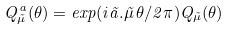<formula> <loc_0><loc_0><loc_500><loc_500>Q ^ { a } _ { \vec { \mu } } ( \theta ) = e x p ( i \vec { a } . \vec { \mu } \, \theta / 2 \pi ) Q _ { \vec { \mu } } ( \theta )</formula> 